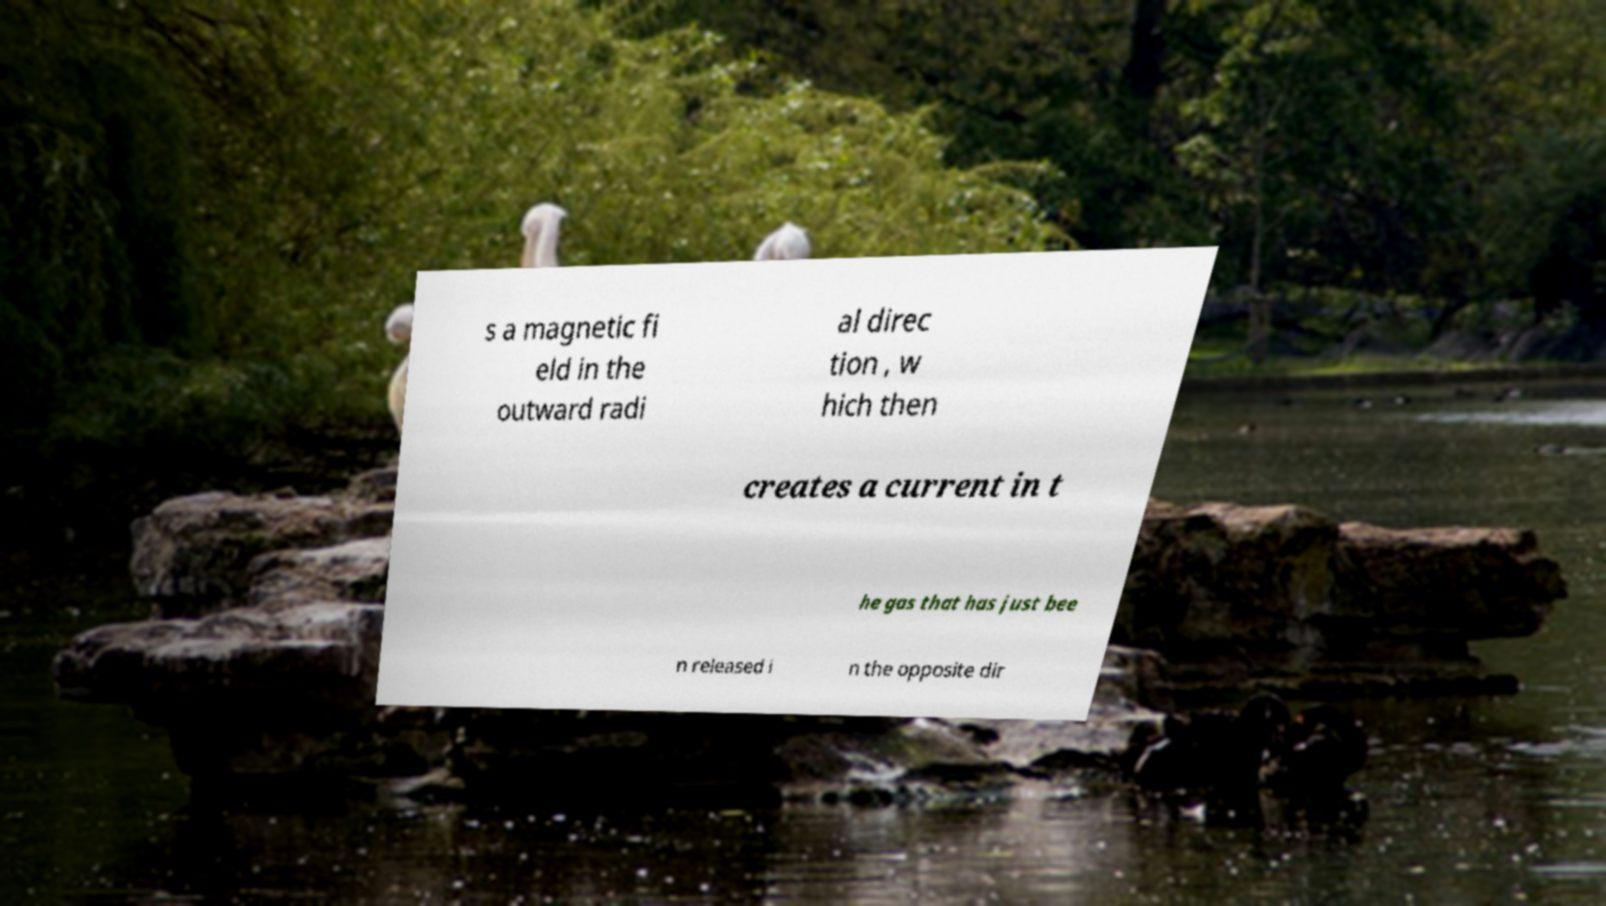What messages or text are displayed in this image? I need them in a readable, typed format. s a magnetic fi eld in the outward radi al direc tion , w hich then creates a current in t he gas that has just bee n released i n the opposite dir 